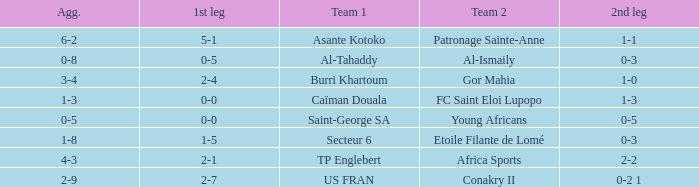Which team lost 0-3 and 0-5? Al-Tahaddy. 